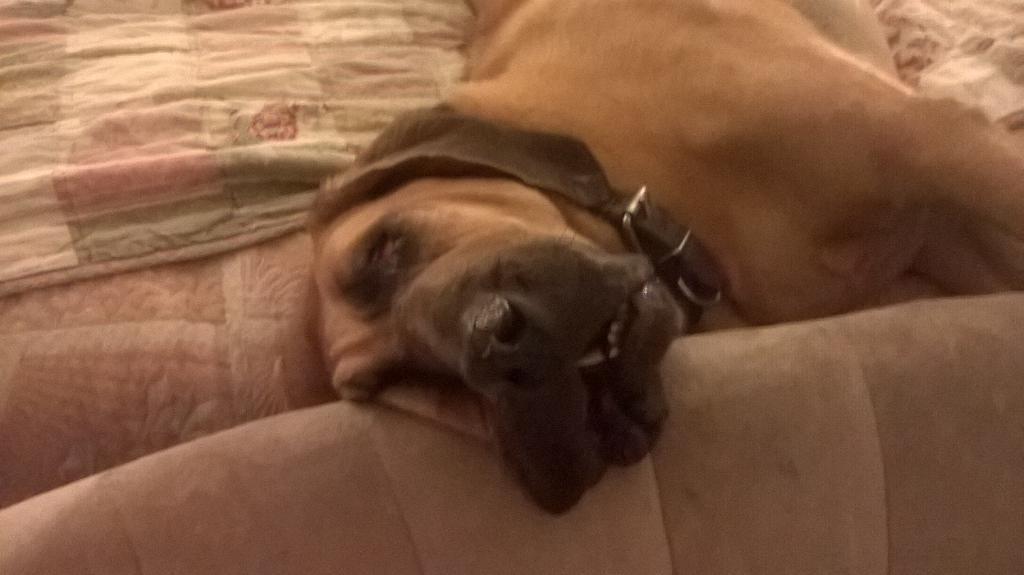How would you summarize this image in a sentence or two? In this image in the center there is one dog and at the bottom there is a bed, on the bed there is a blanket. 